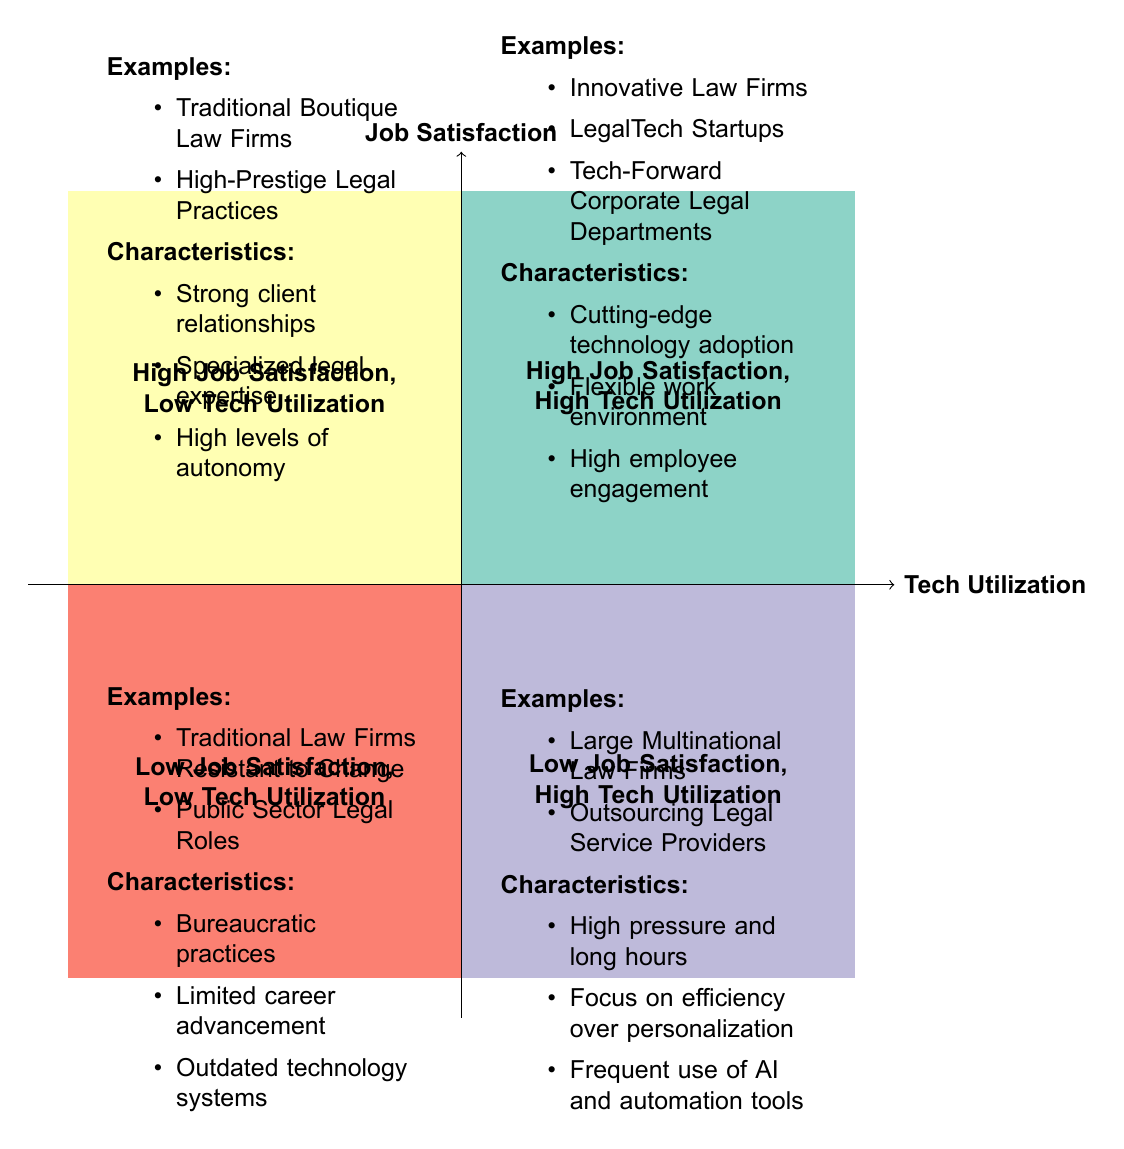What quadrant represents law firms with high job satisfaction and high tech utilization? The quadrant that matches these criteria is located in the upper right section of the diagram and is labeled "High Job Satisfaction, High Tech Utilization".
Answer: High Job Satisfaction, High Tech Utilization How many examples of firms are listed in the "Low Job Satisfaction, High Tech Utilization" quadrant? The "Low Job Satisfaction, High Tech Utilization" quadrant contains two examples listed in the diagram: "Large Multinational Law Firms" and "Outsourcing Legal Service Providers".
Answer: 2 What common characteristic do firms in the "High Job Satisfaction, Low Tech Utilization" quadrant share? The unique shared characteristic within this quadrant is "Strong client relationships," which is mentioned in the list under this quadrant.
Answer: Strong client relationships Which quadrant is characterized by "Bureaucratic practices"? The characteristic "Bureaucratic practices" is found in the quadrant labeled "Low Job Satisfaction, Low Tech Utilization," located in the bottom left corner of the diagram.
Answer: Low Job Satisfaction, Low Tech Utilization In which quadrant would you find firms utilizing AI and automation tools frequently? Firms that frequently use "AI and automation tools" are located in the "Low Job Satisfaction, High Tech Utilization" quadrant indicated on the lower right side of the diagram.
Answer: Low Job Satisfaction, High Tech Utilization What is a common distinction between firms in the "High Job Satisfaction, High Tech Utilization" quadrant and those in the "Low Job Satisfaction, Low Tech Utilization" quadrant? The distinction rests on job satisfaction and technology adoption, with the former exhibiting high job satisfaction and tech utilization, while the latter has low levels on both measures.
Answer: High vs. Low What type of legal practices are found in the "High Job Satisfaction, Low Tech Utilization" quadrant? The listed types of legal practices in this quadrant include “Traditional Boutique Law Firms” and “High-Prestige Legal Practices,” located in the upper left section of the diagram.
Answer: Traditional Boutique Law Firms, High-Prestige Legal Practices What is a defining feature of "Large Multinational Law Firms" as shown in the quadrant chart? A defining feature of "Large Multinational Law Firms," found in the "Low Job Satisfaction, High Tech Utilization" quadrant, is their "High pressure and long hours" work environment, noted in the characteristics of that quadrant.
Answer: High pressure and long hours How is employee engagement characterized in innovative law firms? Employee engagement in innovative law firms is characterized as "High employee engagement," which is listed as a key characteristic in the "High Job Satisfaction, High Tech Utilization" quadrant.
Answer: High employee engagement 